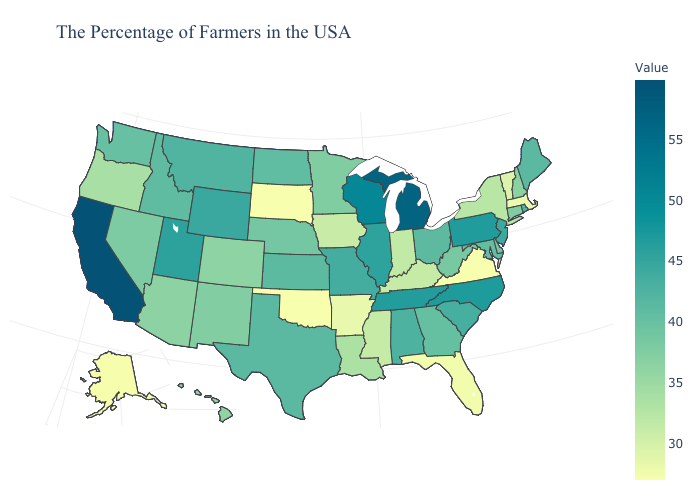Is the legend a continuous bar?
Short answer required. Yes. Which states hav the highest value in the West?
Be succinct. California. Does the map have missing data?
Concise answer only. No. Does Florida have a lower value than Mississippi?
Be succinct. Yes. Which states have the lowest value in the USA?
Concise answer only. Virginia, Oklahoma, South Dakota. 